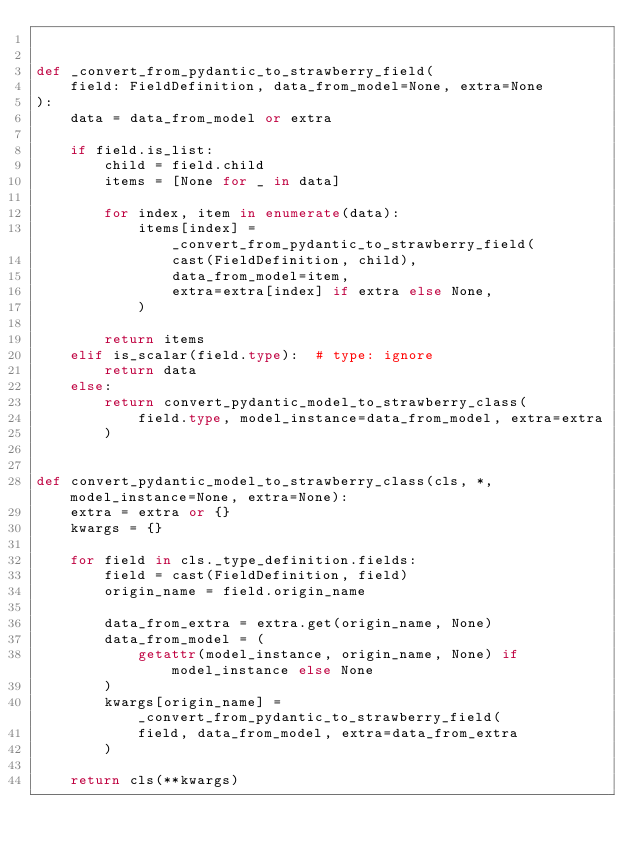<code> <loc_0><loc_0><loc_500><loc_500><_Python_>

def _convert_from_pydantic_to_strawberry_field(
    field: FieldDefinition, data_from_model=None, extra=None
):
    data = data_from_model or extra

    if field.is_list:
        child = field.child
        items = [None for _ in data]

        for index, item in enumerate(data):
            items[index] = _convert_from_pydantic_to_strawberry_field(
                cast(FieldDefinition, child),
                data_from_model=item,
                extra=extra[index] if extra else None,
            )

        return items
    elif is_scalar(field.type):  # type: ignore
        return data
    else:
        return convert_pydantic_model_to_strawberry_class(
            field.type, model_instance=data_from_model, extra=extra
        )


def convert_pydantic_model_to_strawberry_class(cls, *, model_instance=None, extra=None):
    extra = extra or {}
    kwargs = {}

    for field in cls._type_definition.fields:
        field = cast(FieldDefinition, field)
        origin_name = field.origin_name

        data_from_extra = extra.get(origin_name, None)
        data_from_model = (
            getattr(model_instance, origin_name, None) if model_instance else None
        )
        kwargs[origin_name] = _convert_from_pydantic_to_strawberry_field(
            field, data_from_model, extra=data_from_extra
        )

    return cls(**kwargs)
</code> 